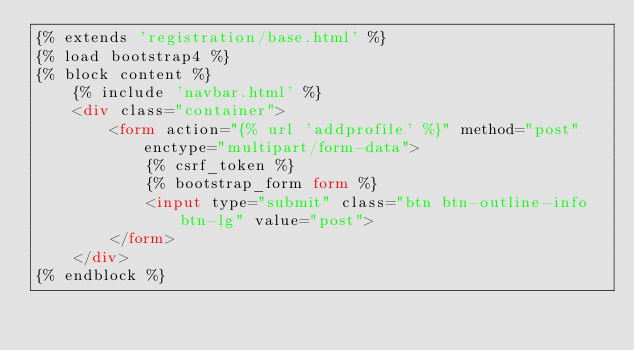<code> <loc_0><loc_0><loc_500><loc_500><_HTML_>{% extends 'registration/base.html' %}
{% load bootstrap4 %}
{% block content %}
    {% include 'navbar.html' %}
    <div class="container">
        <form action="{% url 'addprofile' %}" method="post" enctype="multipart/form-data">
            {% csrf_token %}
            {% bootstrap_form form %}
            <input type="submit" class="btn btn-outline-info btn-lg" value="post">
        </form>
    </div>
{% endblock %}</code> 